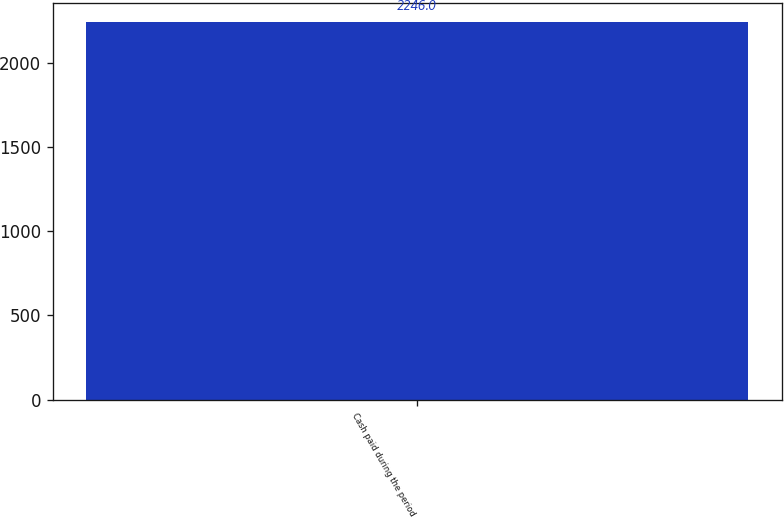Convert chart. <chart><loc_0><loc_0><loc_500><loc_500><bar_chart><fcel>Cash paid during the period<nl><fcel>2246<nl></chart> 